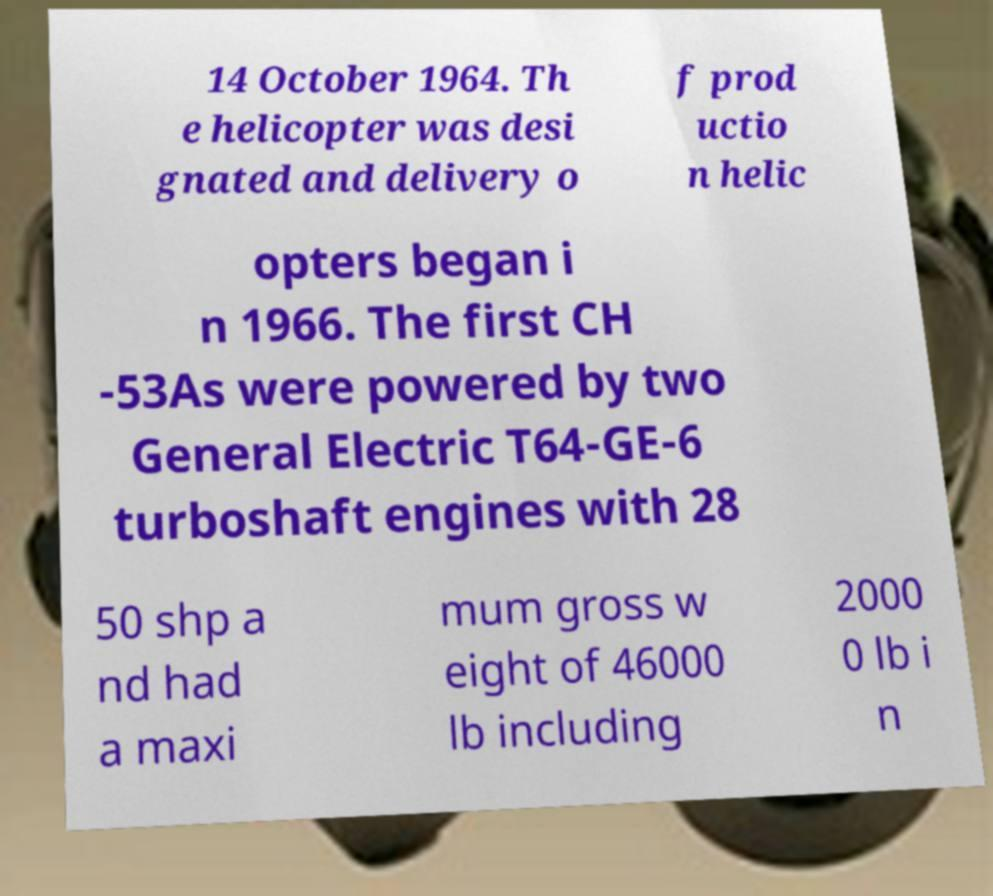What messages or text are displayed in this image? I need them in a readable, typed format. 14 October 1964. Th e helicopter was desi gnated and delivery o f prod uctio n helic opters began i n 1966. The first CH -53As were powered by two General Electric T64-GE-6 turboshaft engines with 28 50 shp a nd had a maxi mum gross w eight of 46000 lb including 2000 0 lb i n 